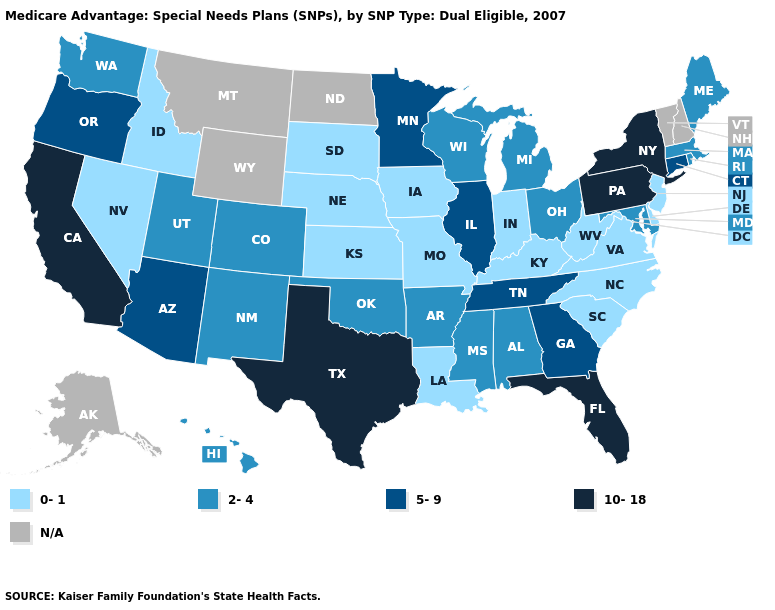What is the highest value in the West ?
Write a very short answer. 10-18. Does Georgia have the highest value in the USA?
Be succinct. No. What is the highest value in states that border North Dakota?
Give a very brief answer. 5-9. Name the states that have a value in the range 10-18?
Give a very brief answer. California, Florida, New York, Pennsylvania, Texas. Which states have the lowest value in the MidWest?
Keep it brief. Iowa, Indiana, Kansas, Missouri, Nebraska, South Dakota. Is the legend a continuous bar?
Answer briefly. No. What is the value of Washington?
Keep it brief. 2-4. Name the states that have a value in the range N/A?
Short answer required. Alaska, Montana, North Dakota, New Hampshire, Vermont, Wyoming. Which states hav the highest value in the West?
Write a very short answer. California. Name the states that have a value in the range 10-18?
Short answer required. California, Florida, New York, Pennsylvania, Texas. Name the states that have a value in the range 2-4?
Keep it brief. Alabama, Arkansas, Colorado, Hawaii, Massachusetts, Maryland, Maine, Michigan, Mississippi, New Mexico, Ohio, Oklahoma, Rhode Island, Utah, Washington, Wisconsin. What is the value of California?
Keep it brief. 10-18. Name the states that have a value in the range 0-1?
Answer briefly. Delaware, Iowa, Idaho, Indiana, Kansas, Kentucky, Louisiana, Missouri, North Carolina, Nebraska, New Jersey, Nevada, South Carolina, South Dakota, Virginia, West Virginia. 